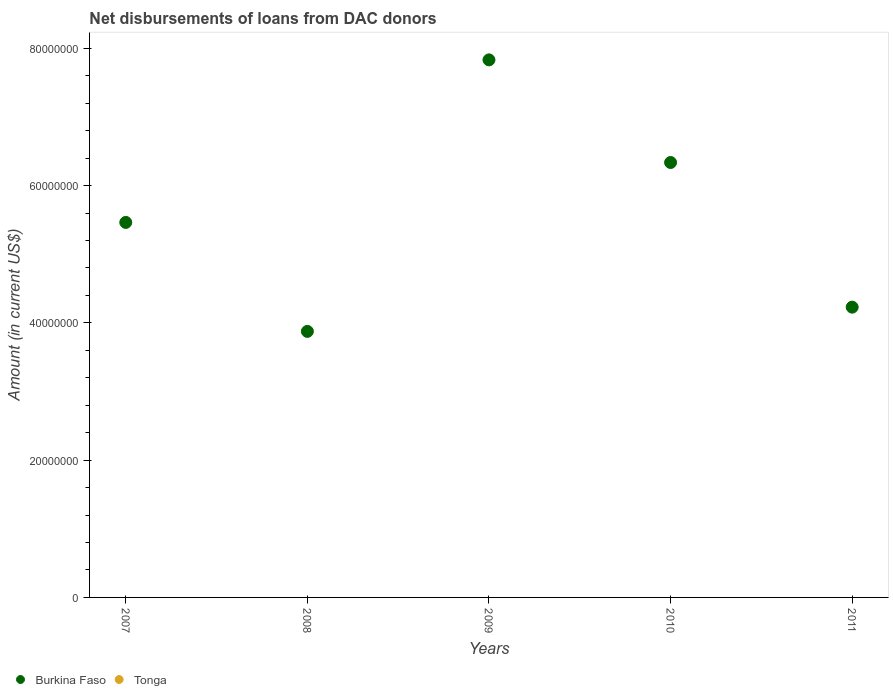Is the number of dotlines equal to the number of legend labels?
Offer a terse response. No. What is the amount of loans disbursed in Tonga in 2009?
Ensure brevity in your answer.  0. Across all years, what is the maximum amount of loans disbursed in Burkina Faso?
Offer a very short reply. 7.83e+07. In which year was the amount of loans disbursed in Burkina Faso maximum?
Keep it short and to the point. 2009. What is the total amount of loans disbursed in Tonga in the graph?
Offer a very short reply. 0. What is the difference between the amount of loans disbursed in Burkina Faso in 2008 and that in 2010?
Offer a terse response. -2.46e+07. What is the difference between the amount of loans disbursed in Tonga in 2007 and the amount of loans disbursed in Burkina Faso in 2009?
Your response must be concise. -7.83e+07. What is the average amount of loans disbursed in Burkina Faso per year?
Offer a terse response. 5.55e+07. In how many years, is the amount of loans disbursed in Burkina Faso greater than 36000000 US$?
Offer a terse response. 5. What is the ratio of the amount of loans disbursed in Burkina Faso in 2007 to that in 2009?
Keep it short and to the point. 0.7. What is the difference between the highest and the second highest amount of loans disbursed in Burkina Faso?
Your answer should be compact. 1.50e+07. What is the difference between the highest and the lowest amount of loans disbursed in Burkina Faso?
Keep it short and to the point. 3.96e+07. In how many years, is the amount of loans disbursed in Tonga greater than the average amount of loans disbursed in Tonga taken over all years?
Keep it short and to the point. 0. Is the sum of the amount of loans disbursed in Burkina Faso in 2007 and 2010 greater than the maximum amount of loans disbursed in Tonga across all years?
Offer a very short reply. Yes. Does the amount of loans disbursed in Tonga monotonically increase over the years?
Provide a short and direct response. No. How many years are there in the graph?
Keep it short and to the point. 5. Are the values on the major ticks of Y-axis written in scientific E-notation?
Keep it short and to the point. No. Does the graph contain grids?
Ensure brevity in your answer.  No. How are the legend labels stacked?
Give a very brief answer. Horizontal. What is the title of the graph?
Your answer should be compact. Net disbursements of loans from DAC donors. Does "Korea (Democratic)" appear as one of the legend labels in the graph?
Keep it short and to the point. No. What is the label or title of the X-axis?
Provide a succinct answer. Years. What is the label or title of the Y-axis?
Give a very brief answer. Amount (in current US$). What is the Amount (in current US$) in Burkina Faso in 2007?
Keep it short and to the point. 5.46e+07. What is the Amount (in current US$) of Tonga in 2007?
Your response must be concise. 0. What is the Amount (in current US$) in Burkina Faso in 2008?
Your answer should be very brief. 3.88e+07. What is the Amount (in current US$) of Burkina Faso in 2009?
Offer a terse response. 7.83e+07. What is the Amount (in current US$) of Tonga in 2009?
Provide a succinct answer. 0. What is the Amount (in current US$) in Burkina Faso in 2010?
Keep it short and to the point. 6.34e+07. What is the Amount (in current US$) of Burkina Faso in 2011?
Your answer should be very brief. 4.23e+07. What is the Amount (in current US$) of Tonga in 2011?
Your response must be concise. 0. Across all years, what is the maximum Amount (in current US$) of Burkina Faso?
Keep it short and to the point. 7.83e+07. Across all years, what is the minimum Amount (in current US$) of Burkina Faso?
Your answer should be compact. 3.88e+07. What is the total Amount (in current US$) of Burkina Faso in the graph?
Give a very brief answer. 2.77e+08. What is the difference between the Amount (in current US$) in Burkina Faso in 2007 and that in 2008?
Give a very brief answer. 1.59e+07. What is the difference between the Amount (in current US$) of Burkina Faso in 2007 and that in 2009?
Keep it short and to the point. -2.37e+07. What is the difference between the Amount (in current US$) in Burkina Faso in 2007 and that in 2010?
Provide a succinct answer. -8.73e+06. What is the difference between the Amount (in current US$) in Burkina Faso in 2007 and that in 2011?
Make the answer very short. 1.23e+07. What is the difference between the Amount (in current US$) of Burkina Faso in 2008 and that in 2009?
Your answer should be compact. -3.96e+07. What is the difference between the Amount (in current US$) in Burkina Faso in 2008 and that in 2010?
Your answer should be very brief. -2.46e+07. What is the difference between the Amount (in current US$) in Burkina Faso in 2008 and that in 2011?
Your answer should be very brief. -3.53e+06. What is the difference between the Amount (in current US$) in Burkina Faso in 2009 and that in 2010?
Provide a short and direct response. 1.50e+07. What is the difference between the Amount (in current US$) of Burkina Faso in 2009 and that in 2011?
Give a very brief answer. 3.60e+07. What is the difference between the Amount (in current US$) in Burkina Faso in 2010 and that in 2011?
Keep it short and to the point. 2.11e+07. What is the average Amount (in current US$) of Burkina Faso per year?
Give a very brief answer. 5.55e+07. What is the ratio of the Amount (in current US$) of Burkina Faso in 2007 to that in 2008?
Offer a very short reply. 1.41. What is the ratio of the Amount (in current US$) of Burkina Faso in 2007 to that in 2009?
Keep it short and to the point. 0.7. What is the ratio of the Amount (in current US$) of Burkina Faso in 2007 to that in 2010?
Provide a succinct answer. 0.86. What is the ratio of the Amount (in current US$) in Burkina Faso in 2007 to that in 2011?
Your response must be concise. 1.29. What is the ratio of the Amount (in current US$) of Burkina Faso in 2008 to that in 2009?
Your response must be concise. 0.49. What is the ratio of the Amount (in current US$) of Burkina Faso in 2008 to that in 2010?
Offer a very short reply. 0.61. What is the ratio of the Amount (in current US$) in Burkina Faso in 2008 to that in 2011?
Keep it short and to the point. 0.92. What is the ratio of the Amount (in current US$) in Burkina Faso in 2009 to that in 2010?
Provide a succinct answer. 1.24. What is the ratio of the Amount (in current US$) in Burkina Faso in 2009 to that in 2011?
Ensure brevity in your answer.  1.85. What is the ratio of the Amount (in current US$) in Burkina Faso in 2010 to that in 2011?
Provide a succinct answer. 1.5. What is the difference between the highest and the second highest Amount (in current US$) of Burkina Faso?
Make the answer very short. 1.50e+07. What is the difference between the highest and the lowest Amount (in current US$) in Burkina Faso?
Make the answer very short. 3.96e+07. 